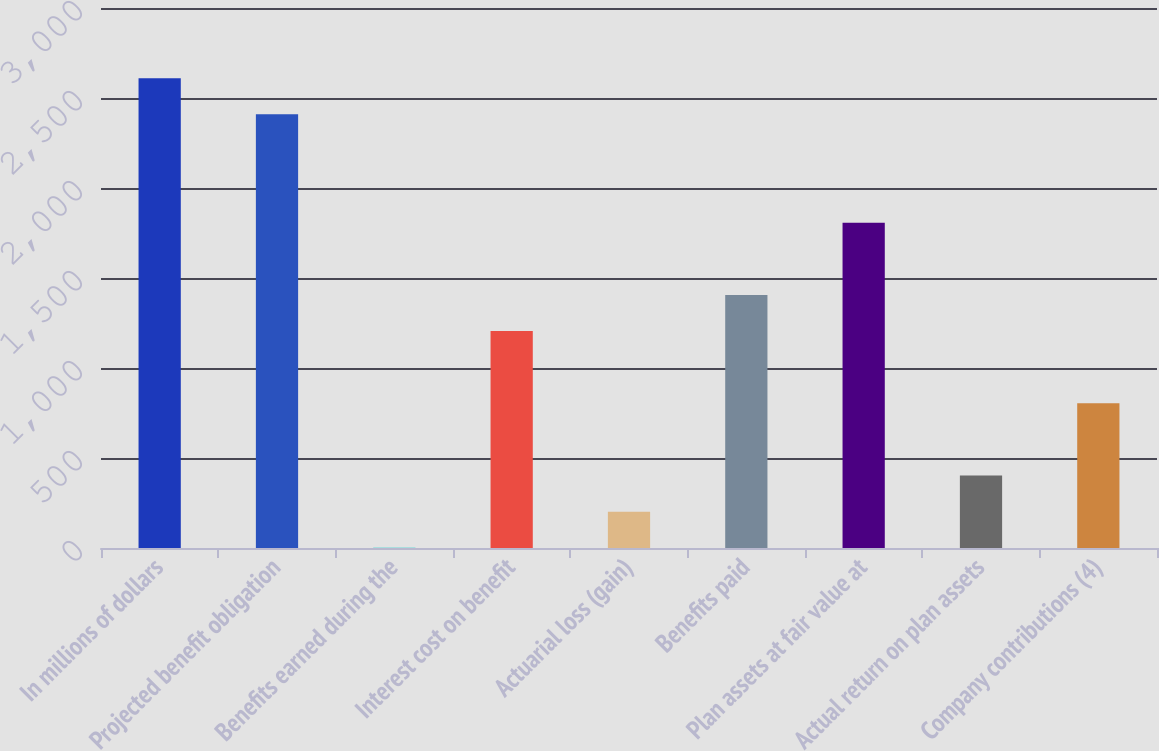Convert chart. <chart><loc_0><loc_0><loc_500><loc_500><bar_chart><fcel>In millions of dollars<fcel>Projected benefit obligation<fcel>Benefits earned during the<fcel>Interest cost on benefit<fcel>Actuarial loss (gain)<fcel>Benefits paid<fcel>Plan assets at fair value at<fcel>Actual return on plan assets<fcel>Company contributions (4)<nl><fcel>2610.1<fcel>2409.4<fcel>1<fcel>1205.2<fcel>201.7<fcel>1405.9<fcel>1807.3<fcel>402.4<fcel>803.8<nl></chart> 